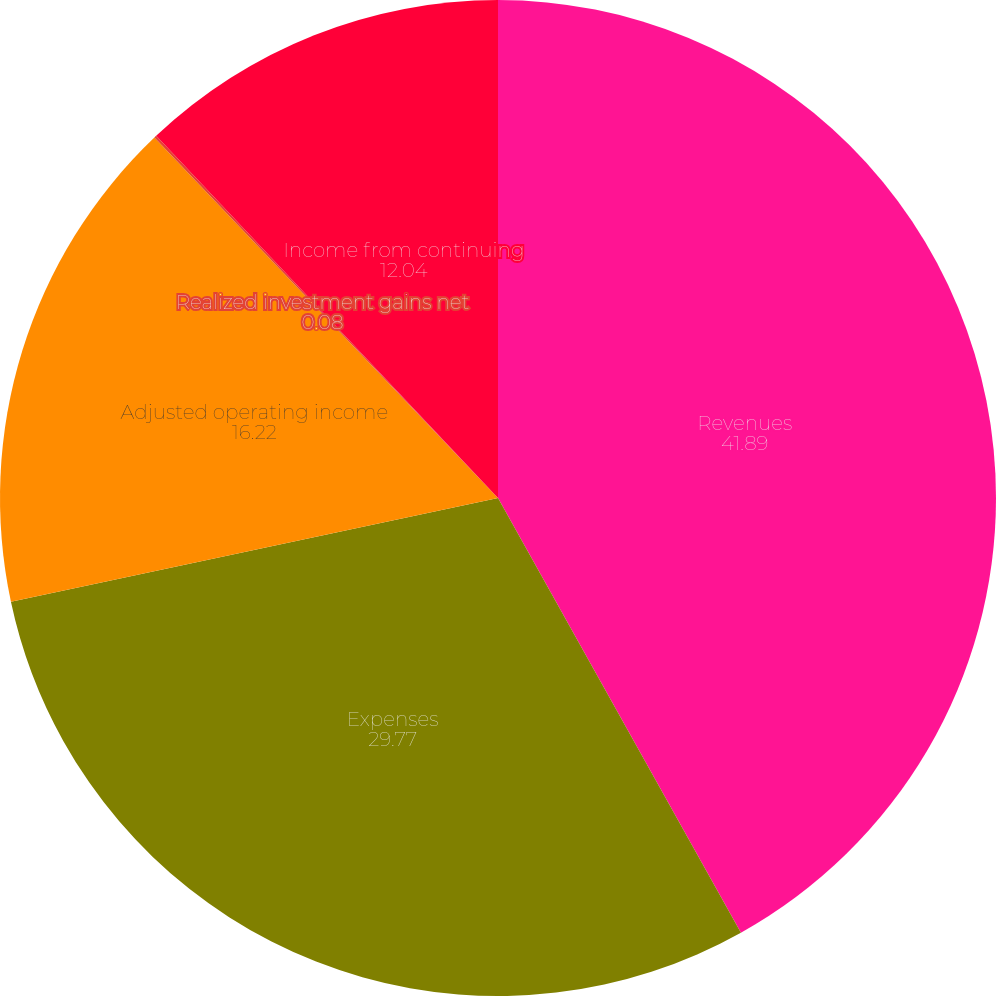<chart> <loc_0><loc_0><loc_500><loc_500><pie_chart><fcel>Revenues<fcel>Expenses<fcel>Adjusted operating income<fcel>Realized investment gains net<fcel>Income from continuing<nl><fcel>41.89%<fcel>29.77%<fcel>16.22%<fcel>0.08%<fcel>12.04%<nl></chart> 